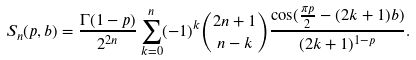Convert formula to latex. <formula><loc_0><loc_0><loc_500><loc_500>S _ { n } ( p , b ) = \frac { \Gamma ( 1 - p ) } { 2 ^ { 2 n } } \sum _ { k = 0 } ^ { n } ( - 1 ) ^ { k } \binom { 2 n + 1 } { n - k } \frac { \cos ( \frac { \pi p } { 2 } - ( 2 k + 1 ) b ) } { ( 2 k + 1 ) ^ { 1 - p } } .</formula> 